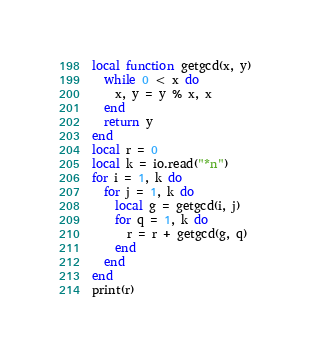<code> <loc_0><loc_0><loc_500><loc_500><_Lua_>local function getgcd(x, y)
  while 0 < x do
    x, y = y % x, x
  end
  return y
end
local r = 0
local k = io.read("*n")
for i = 1, k do
  for j = 1, k do
    local g = getgcd(i, j)
    for q = 1, k do
      r = r + getgcd(g, q)
    end
  end
end
print(r)
</code> 